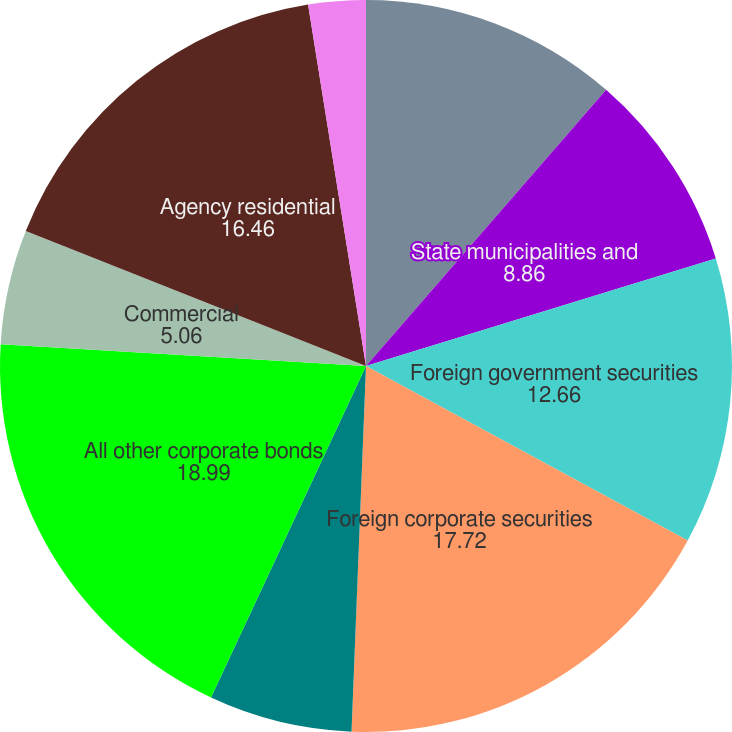Convert chart to OTSL. <chart><loc_0><loc_0><loc_500><loc_500><pie_chart><fcel>US government and government<fcel>State municipalities and<fcel>Foreign government securities<fcel>Foreign corporate securities<fcel>Public utilities<fcel>All other corporate bonds<fcel>Commercial<fcel>Agency residential<fcel>Non-agency residential<fcel>Redeemable preferred stock<nl><fcel>11.39%<fcel>8.86%<fcel>12.66%<fcel>17.72%<fcel>6.33%<fcel>18.99%<fcel>5.06%<fcel>16.46%<fcel>0.0%<fcel>2.53%<nl></chart> 